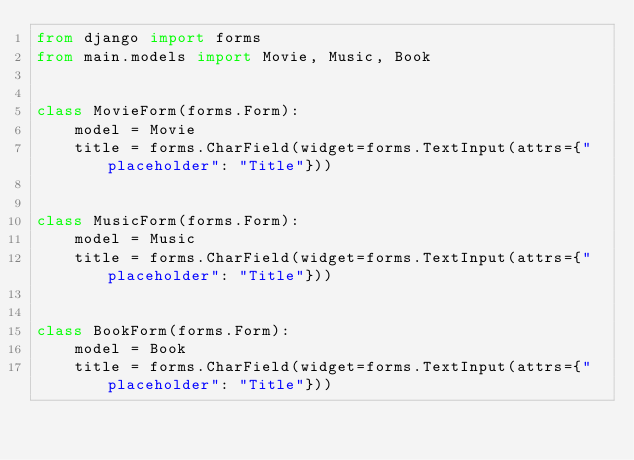<code> <loc_0><loc_0><loc_500><loc_500><_Python_>from django import forms
from main.models import Movie, Music, Book


class MovieForm(forms.Form):
    model = Movie
    title = forms.CharField(widget=forms.TextInput(attrs={"placeholder": "Title"}))


class MusicForm(forms.Form):
    model = Music
    title = forms.CharField(widget=forms.TextInput(attrs={"placeholder": "Title"}))


class BookForm(forms.Form):
    model = Book
    title = forms.CharField(widget=forms.TextInput(attrs={"placeholder": "Title"}))
</code> 